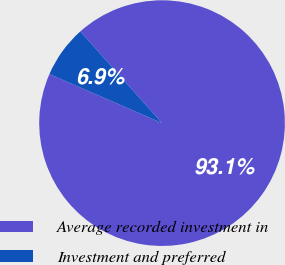Convert chart to OTSL. <chart><loc_0><loc_0><loc_500><loc_500><pie_chart><fcel>Average recorded investment in<fcel>Investment and preferred<nl><fcel>93.12%<fcel>6.88%<nl></chart> 